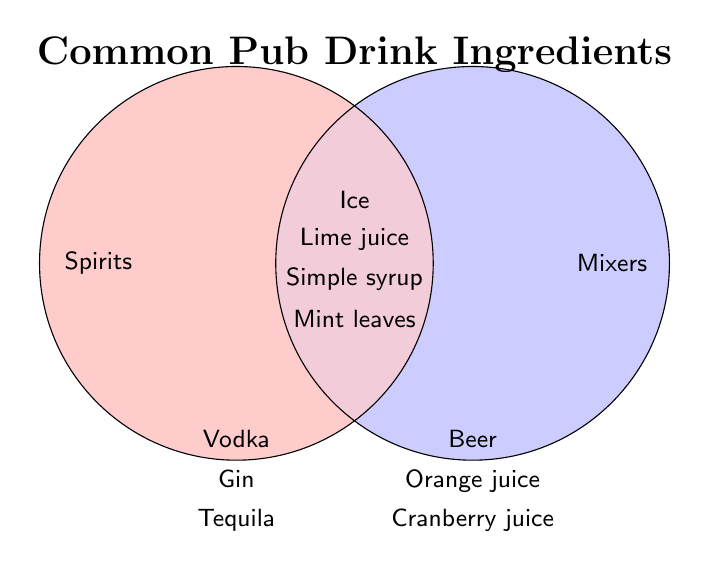What's the title of the Venn Diagram? The title is located at the top of the Venn Diagram. It is written in large, bold font for easy identification.
Answer: Common Pub Drink Ingredients What categories are compared in the Venn Diagram? The categories are labeled beside the circles. One is on the left and the other is on the right.
Answer: Spirits and Mixers Which category does Vodka belong to? Vodka is listed under the circle on the left side. The left circle represents "Spirits."
Answer: Spirits What is the common ingredient between Spirits and Mixers labeled in the Venn Diagram intersection that is also something you add to many drinks to cool them down? The ingredient in the intersection, which cools drinks, is listed towards the center of the Venn Diagram.
Answer: Ice Name two ingredients found in the Mixers category only. Look at the right circle labeled "Mixers" and list two distinct items.
Answer: Beer, Cranberry juice Which ingredients are shared between Spirits and Mixers? The shared ingredients are located at the intersection in the center of both circles.
Answer: Ice, Lime juice, Simple syrup, Mint leaves Which category has more unique ingredients, Spirits or Mixers? Count the unique ingredients within each circle separately excluding the center shared area, and compare the numbers.
Answer: Spirits Identify one ingredient that is used only in pub drinks made up of Spirits. Check the ingredients listed solely within the left circle labeled "Spirits."
Answer: Gin 